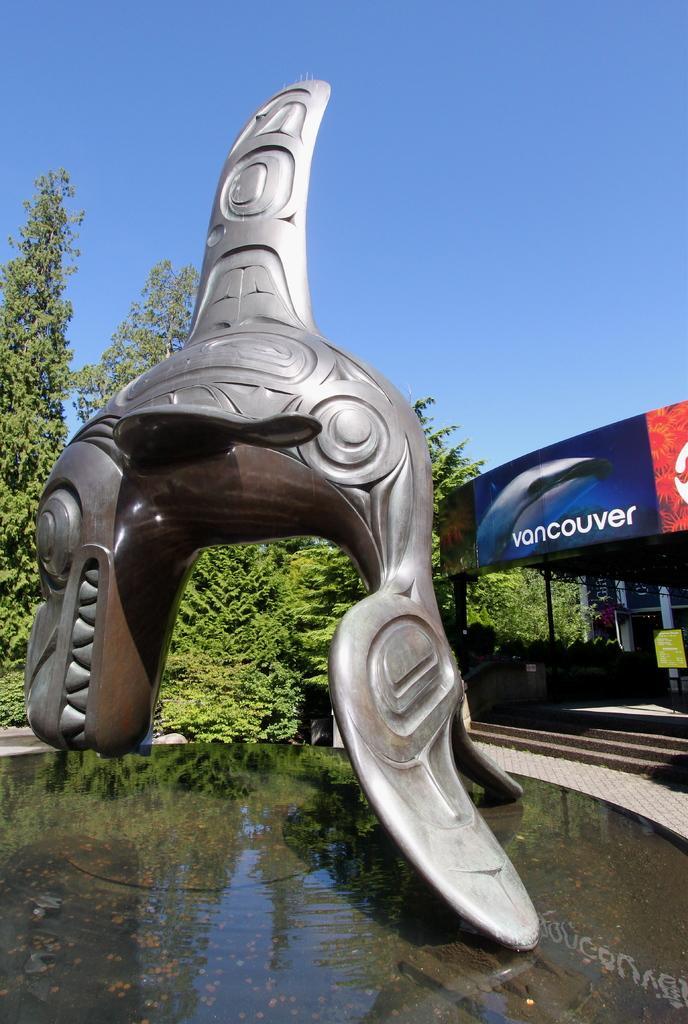Could you give a brief overview of what you see in this image? In this image, we can see an object. We can see some water and a few boards with text and images. There are a few poles and stairs. We can see some trees and the sky. We can also see some reflection in the water. 